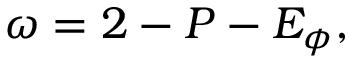Convert formula to latex. <formula><loc_0><loc_0><loc_500><loc_500>\omega = 2 - P - E _ { \phi } ,</formula> 